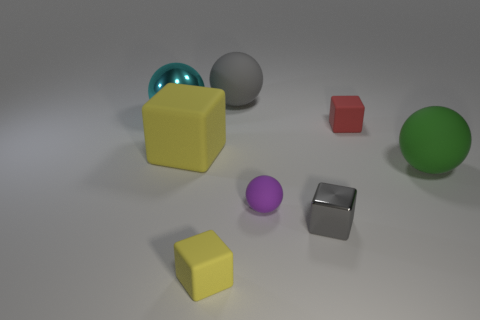Are there any yellow things to the right of the small red rubber block?
Provide a short and direct response. No. Are there fewer large metallic spheres in front of the gray metal cube than small yellow matte objects?
Your response must be concise. Yes. What material is the large cyan object?
Provide a short and direct response. Metal. What is the color of the small metal cube?
Your answer should be compact. Gray. There is a cube that is both behind the tiny gray thing and on the left side of the purple rubber thing; what color is it?
Ensure brevity in your answer.  Yellow. Is there any other thing that is made of the same material as the big gray ball?
Provide a succinct answer. Yes. Is the gray block made of the same material as the yellow block behind the small yellow matte object?
Make the answer very short. No. There is a rubber block that is in front of the big ball right of the red block; what is its size?
Make the answer very short. Small. Are there any other things that are the same color as the metallic sphere?
Your answer should be very brief. No. Do the yellow thing that is behind the gray metallic cube and the gray object in front of the big gray sphere have the same material?
Offer a terse response. No. 